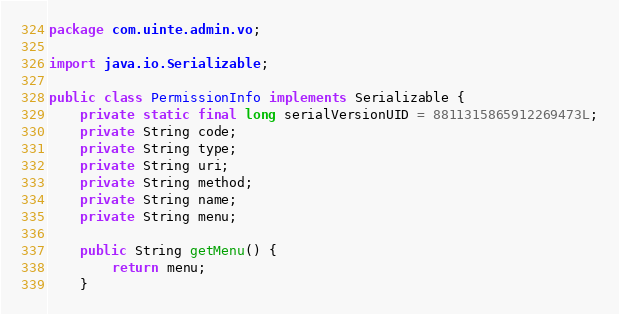<code> <loc_0><loc_0><loc_500><loc_500><_Java_>package com.uinte.admin.vo;

import java.io.Serializable;

public class PermissionInfo implements Serializable {
	private static final long serialVersionUID = 8811315865912269473L;
	private String code;
	private String type;
	private String uri;
	private String method;
	private String name;
	private String menu;

	public String getMenu() {
		return menu;
	}
</code> 